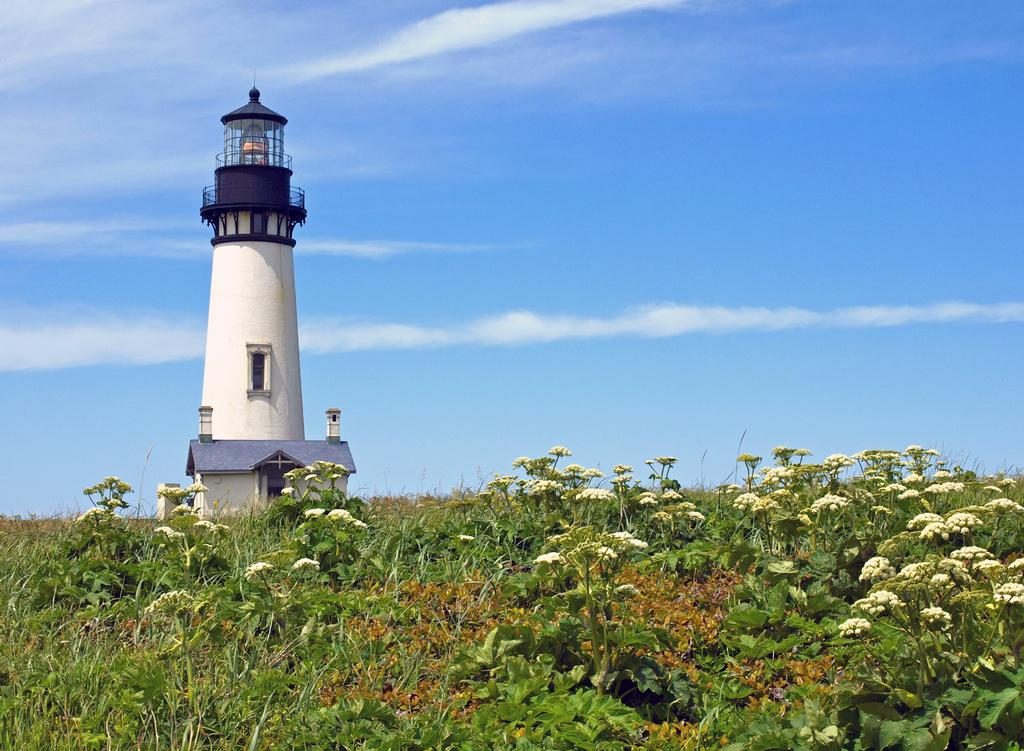What types of vegetation are in the foreground of the image? There are plants and flowers in the foreground of the image. What structure is located in the center of the image? There is a lighthouse in the center of the image. How would you describe the weather in the image? The sky is sunny, indicating good weather. Where are the cattle grazing in the image? There are no cattle present in the image. What direction does the duck fly in the image? There are no ducks present in the image. 